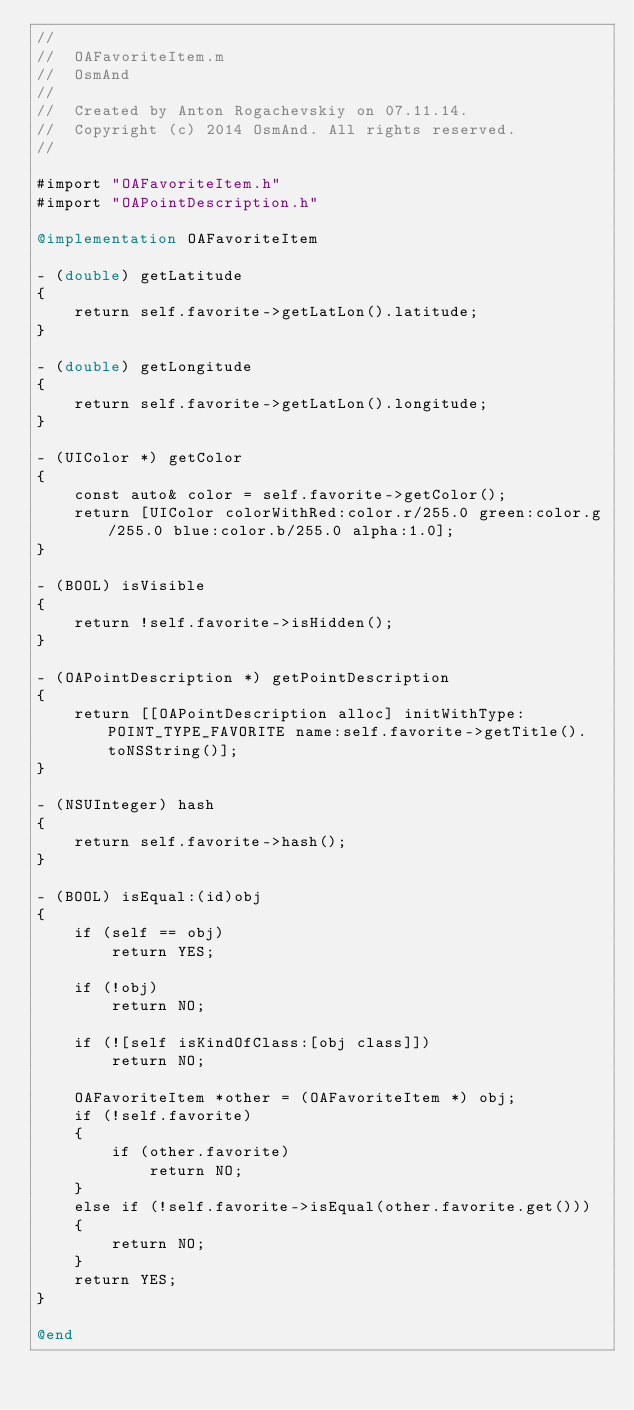<code> <loc_0><loc_0><loc_500><loc_500><_ObjectiveC_>//
//  OAFavoriteItem.m
//  OsmAnd
//
//  Created by Anton Rogachevskiy on 07.11.14.
//  Copyright (c) 2014 OsmAnd. All rights reserved.
//

#import "OAFavoriteItem.h"
#import "OAPointDescription.h"

@implementation OAFavoriteItem

- (double) getLatitude
{
    return self.favorite->getLatLon().latitude;
}

- (double) getLongitude
{
    return self.favorite->getLatLon().longitude;
}

- (UIColor *) getColor
{
    const auto& color = self.favorite->getColor();
    return [UIColor colorWithRed:color.r/255.0 green:color.g/255.0 blue:color.b/255.0 alpha:1.0];
}

- (BOOL) isVisible
{
    return !self.favorite->isHidden();
}

- (OAPointDescription *) getPointDescription
{
    return [[OAPointDescription alloc] initWithType:POINT_TYPE_FAVORITE name:self.favorite->getTitle().toNSString()];
}

- (NSUInteger) hash
{
    return self.favorite->hash();
}

- (BOOL) isEqual:(id)obj
{
    if (self == obj)
        return YES;
    
    if (!obj)
        return NO;
    
    if (![self isKindOfClass:[obj class]])
        return NO;
    
    OAFavoriteItem *other = (OAFavoriteItem *) obj;
    if (!self.favorite)
    {
        if (other.favorite)
            return NO;
    }
    else if (!self.favorite->isEqual(other.favorite.get()))
    {
        return NO;
    }
    return YES;
}

@end
</code> 